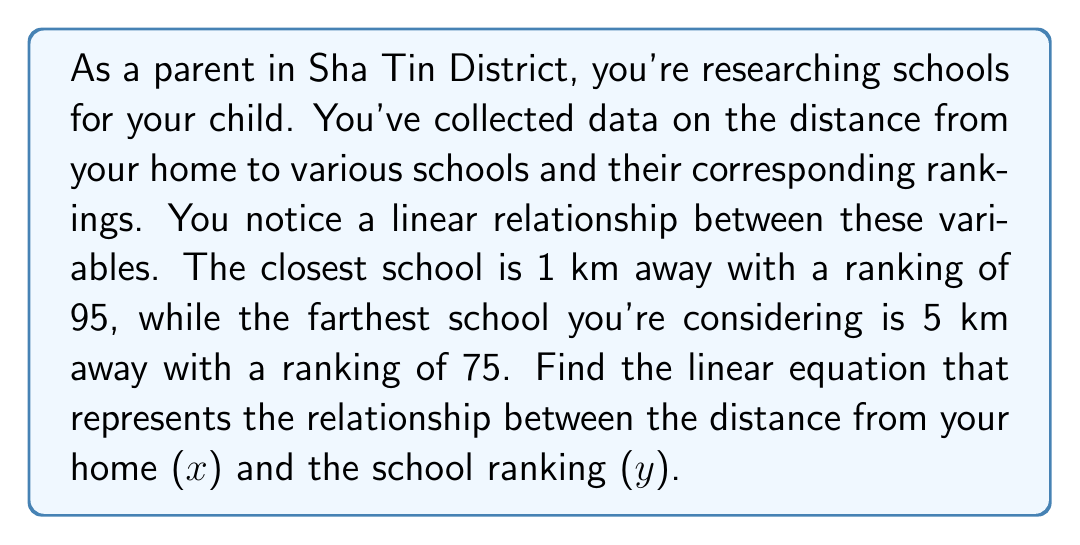Solve this math problem. To find the linear equation, we'll use the point-slope form: $y - y_1 = m(x - x_1)$, where m is the slope.

1. Identify two points:
   $(x_1, y_1) = (1, 95)$ (closest school)
   $(x_2, y_2) = (5, 75)$ (farthest school)

2. Calculate the slope (m):
   $$m = \frac{y_2 - y_1}{x_2 - x_1} = \frac{75 - 95}{5 - 1} = \frac{-20}{4} = -5$$

3. Use the point-slope form with $(x_1, y_1) = (1, 95)$:
   $y - 95 = -5(x - 1)$

4. Simplify the equation:
   $y - 95 = -5x + 5$
   $y = -5x + 5 + 95$
   $y = -5x + 100$

Therefore, the linear equation representing the relationship between distance from home (x) and school ranking (y) is $y = -5x + 100$.
Answer: $y = -5x + 100$, where $y$ is the school ranking and $x$ is the distance in km from home. 